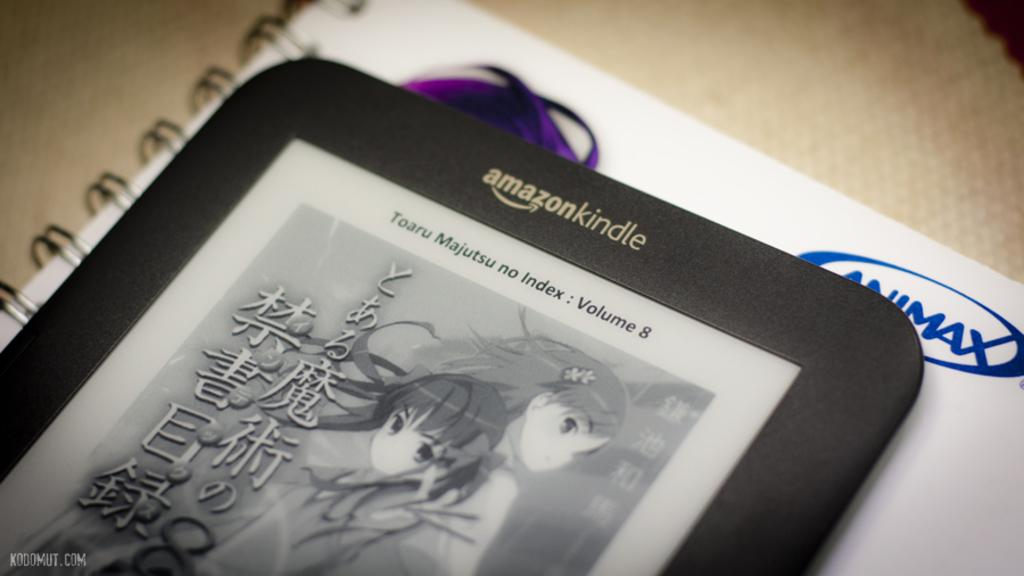<image>
Give a short and clear explanation of the subsequent image. An amazon kindle shows volume 8 of a book. 